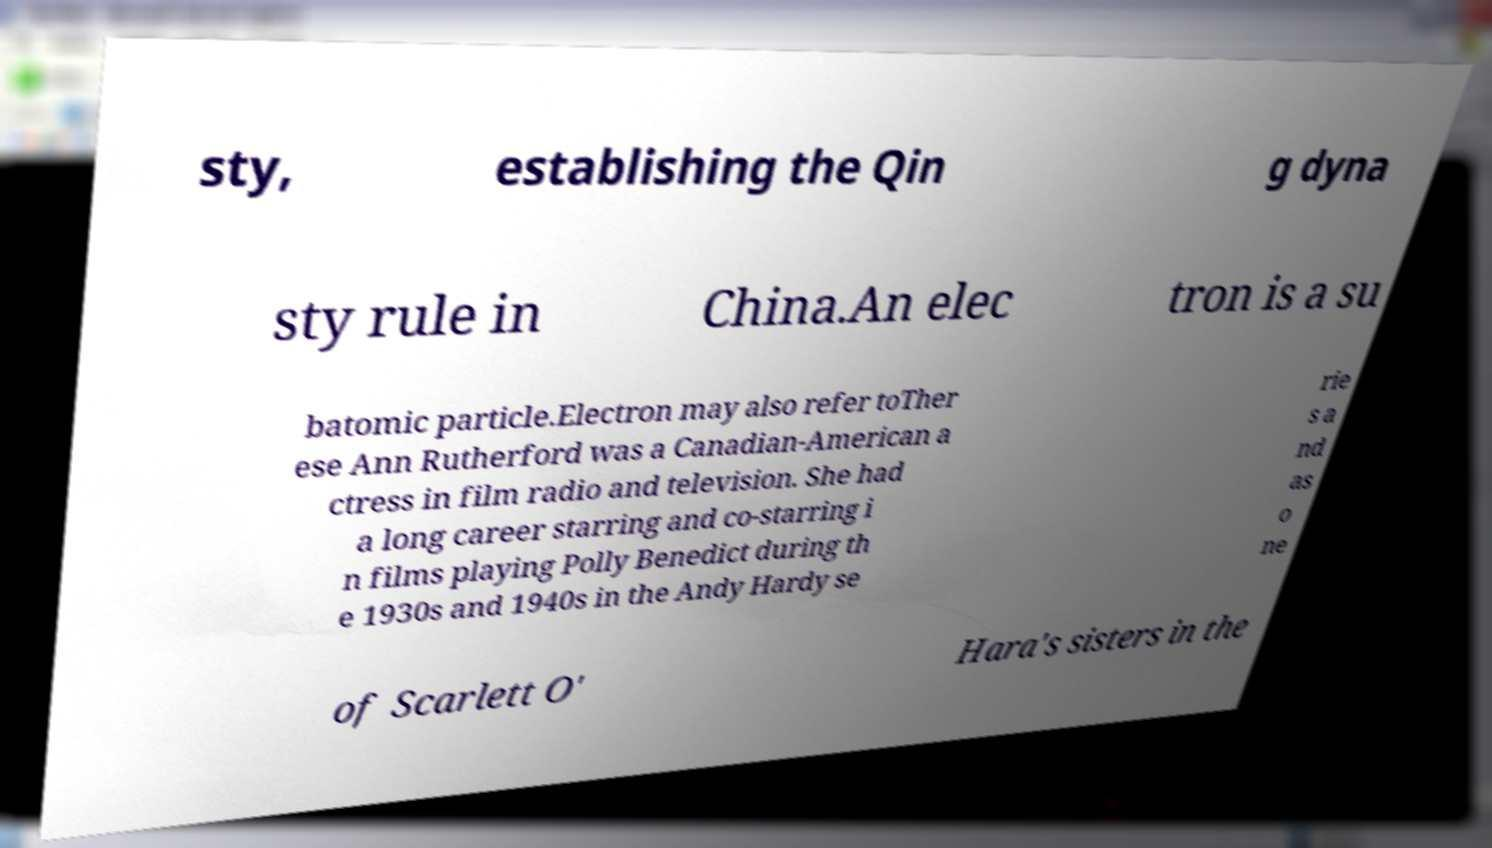What messages or text are displayed in this image? I need them in a readable, typed format. sty, establishing the Qin g dyna sty rule in China.An elec tron is a su batomic particle.Electron may also refer toTher ese Ann Rutherford was a Canadian-American a ctress in film radio and television. She had a long career starring and co-starring i n films playing Polly Benedict during th e 1930s and 1940s in the Andy Hardy se rie s a nd as o ne of Scarlett O' Hara's sisters in the 